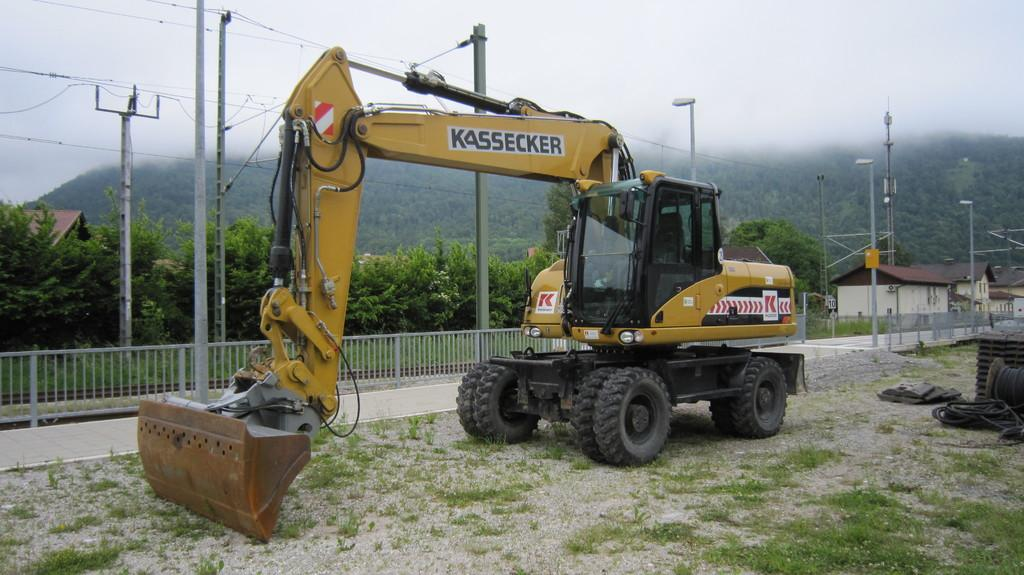What is the main object in the image? There is a crane in the image. What type of environment is around the crane? There is grass around the crane. What other objects are near the crane? There is equipment around the crane. What type of structures can be seen in the image? There are houses in the image. What else can be seen in the image besides the crane and houses? There are poles and trees in the image. What type of comfort can be seen in the image? There is no specific comfort depicted in the image; it features a crane, grass, equipment, houses, poles, and trees. Is there a church visible in the image? No, there is no church present in the image. 